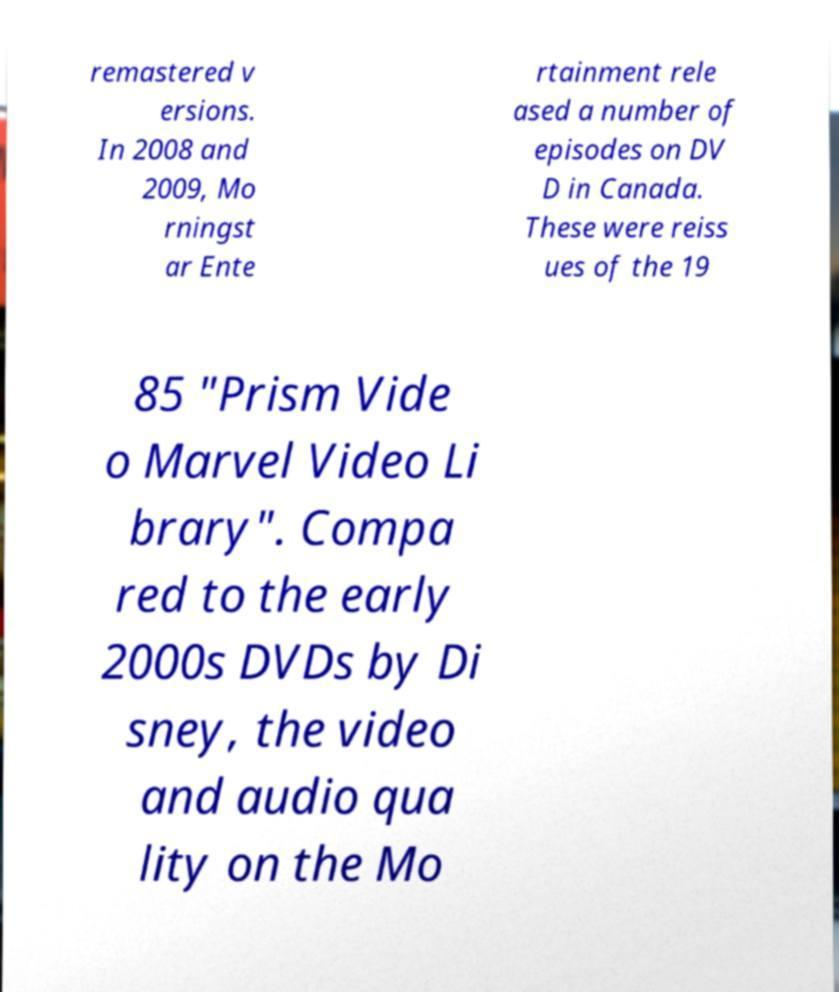Can you read and provide the text displayed in the image?This photo seems to have some interesting text. Can you extract and type it out for me? remastered v ersions. In 2008 and 2009, Mo rningst ar Ente rtainment rele ased a number of episodes on DV D in Canada. These were reiss ues of the 19 85 "Prism Vide o Marvel Video Li brary". Compa red to the early 2000s DVDs by Di sney, the video and audio qua lity on the Mo 